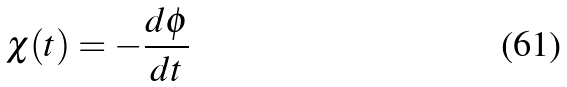Convert formula to latex. <formula><loc_0><loc_0><loc_500><loc_500>\chi ( t ) = - \frac { d \phi } { d t }</formula> 